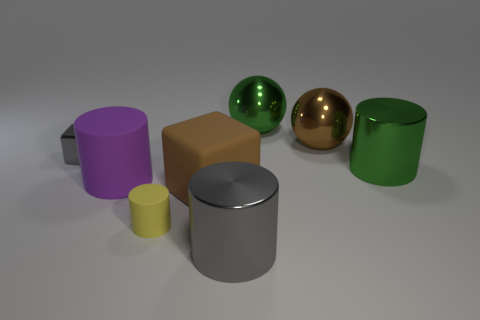Do the green sphere and the brown object that is behind the metal cube have the same size? The green sphere and the brown object, which appears to be a cube, do indeed seem to have a very similar size when comparing their dimensions visually in the image. 